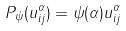Convert formula to latex. <formula><loc_0><loc_0><loc_500><loc_500>P _ { \psi } ( u ^ { \alpha } _ { i j } ) = \psi ( \alpha ) u ^ { \alpha } _ { i j }</formula> 